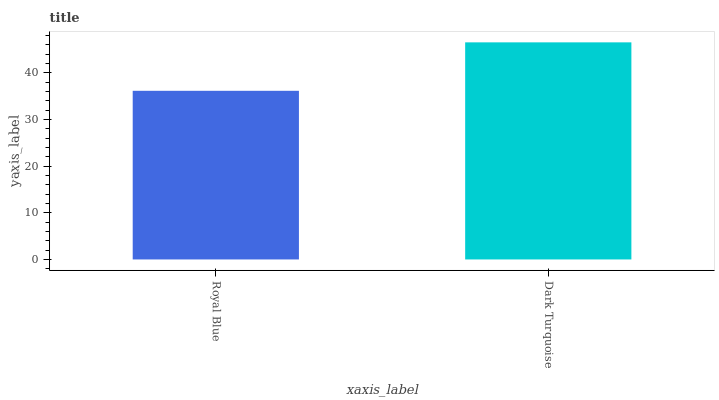Is Dark Turquoise the minimum?
Answer yes or no. No. Is Dark Turquoise greater than Royal Blue?
Answer yes or no. Yes. Is Royal Blue less than Dark Turquoise?
Answer yes or no. Yes. Is Royal Blue greater than Dark Turquoise?
Answer yes or no. No. Is Dark Turquoise less than Royal Blue?
Answer yes or no. No. Is Dark Turquoise the high median?
Answer yes or no. Yes. Is Royal Blue the low median?
Answer yes or no. Yes. Is Royal Blue the high median?
Answer yes or no. No. Is Dark Turquoise the low median?
Answer yes or no. No. 